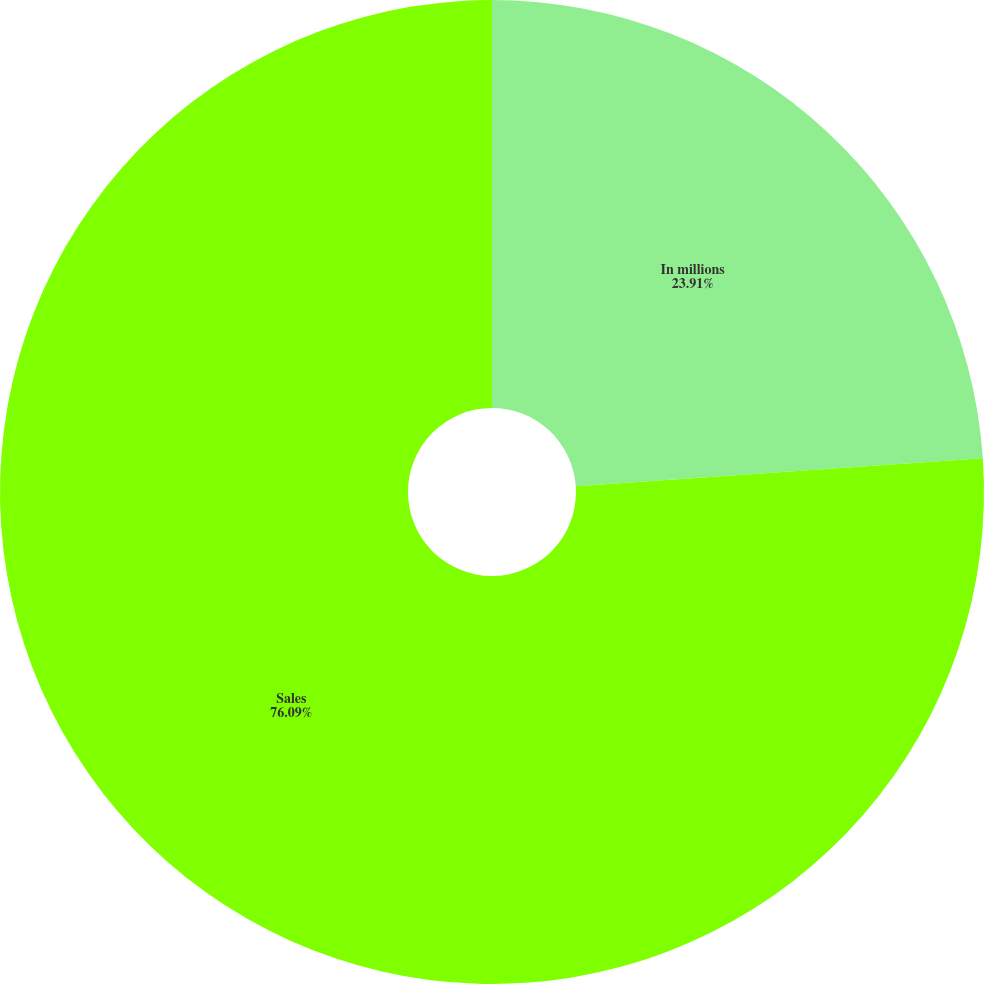Convert chart. <chart><loc_0><loc_0><loc_500><loc_500><pie_chart><fcel>In millions<fcel>Sales<nl><fcel>23.91%<fcel>76.09%<nl></chart> 